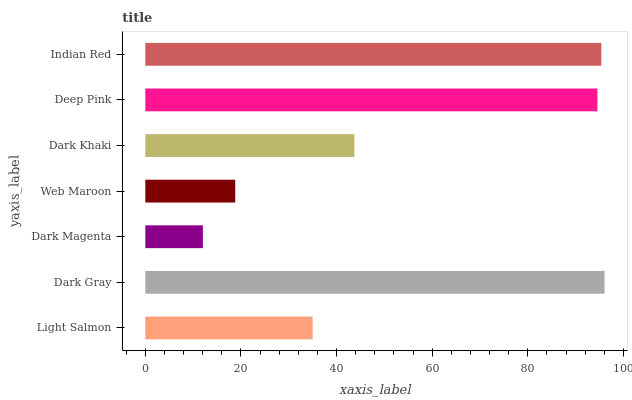Is Dark Magenta the minimum?
Answer yes or no. Yes. Is Dark Gray the maximum?
Answer yes or no. Yes. Is Dark Gray the minimum?
Answer yes or no. No. Is Dark Magenta the maximum?
Answer yes or no. No. Is Dark Gray greater than Dark Magenta?
Answer yes or no. Yes. Is Dark Magenta less than Dark Gray?
Answer yes or no. Yes. Is Dark Magenta greater than Dark Gray?
Answer yes or no. No. Is Dark Gray less than Dark Magenta?
Answer yes or no. No. Is Dark Khaki the high median?
Answer yes or no. Yes. Is Dark Khaki the low median?
Answer yes or no. Yes. Is Dark Gray the high median?
Answer yes or no. No. Is Dark Gray the low median?
Answer yes or no. No. 